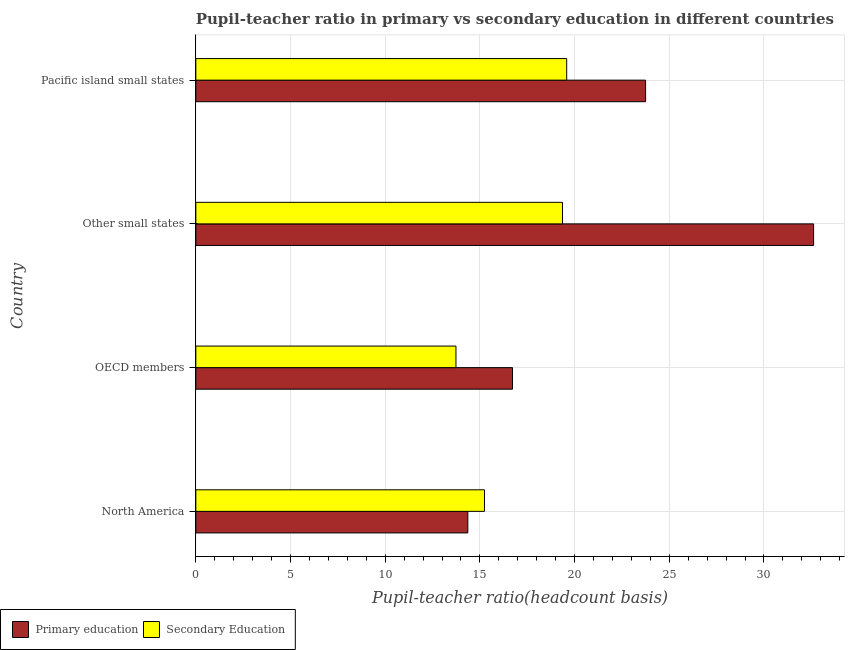How many groups of bars are there?
Make the answer very short. 4. Are the number of bars on each tick of the Y-axis equal?
Provide a short and direct response. Yes. How many bars are there on the 4th tick from the top?
Make the answer very short. 2. How many bars are there on the 2nd tick from the bottom?
Give a very brief answer. 2. What is the pupil-teacher ratio in primary education in OECD members?
Provide a succinct answer. 16.72. Across all countries, what is the maximum pupil teacher ratio on secondary education?
Make the answer very short. 19.58. Across all countries, what is the minimum pupil-teacher ratio in primary education?
Provide a short and direct response. 14.36. In which country was the pupil-teacher ratio in primary education maximum?
Give a very brief answer. Other small states. What is the total pupil teacher ratio on secondary education in the graph?
Offer a very short reply. 67.92. What is the difference between the pupil-teacher ratio in primary education in North America and that in OECD members?
Provide a succinct answer. -2.36. What is the difference between the pupil teacher ratio on secondary education in OECD members and the pupil-teacher ratio in primary education in Other small states?
Provide a short and direct response. -18.89. What is the average pupil teacher ratio on secondary education per country?
Your answer should be compact. 16.98. What is the difference between the pupil teacher ratio on secondary education and pupil-teacher ratio in primary education in OECD members?
Keep it short and to the point. -2.99. In how many countries, is the pupil teacher ratio on secondary education greater than 20 ?
Provide a succinct answer. 0. What is the ratio of the pupil-teacher ratio in primary education in North America to that in Pacific island small states?
Provide a short and direct response. 0.6. Is the pupil-teacher ratio in primary education in North America less than that in Pacific island small states?
Ensure brevity in your answer.  Yes. Is the difference between the pupil teacher ratio on secondary education in North America and Pacific island small states greater than the difference between the pupil-teacher ratio in primary education in North America and Pacific island small states?
Your answer should be compact. Yes. What is the difference between the highest and the second highest pupil teacher ratio on secondary education?
Provide a succinct answer. 0.22. What is the difference between the highest and the lowest pupil-teacher ratio in primary education?
Give a very brief answer. 18.26. What does the 1st bar from the top in Pacific island small states represents?
Make the answer very short. Secondary Education. What does the 2nd bar from the bottom in Pacific island small states represents?
Offer a very short reply. Secondary Education. How many bars are there?
Your answer should be compact. 8. How many countries are there in the graph?
Make the answer very short. 4. What is the difference between two consecutive major ticks on the X-axis?
Your answer should be compact. 5. Are the values on the major ticks of X-axis written in scientific E-notation?
Provide a short and direct response. No. How many legend labels are there?
Offer a terse response. 2. What is the title of the graph?
Your answer should be compact. Pupil-teacher ratio in primary vs secondary education in different countries. Does "Fertility rate" appear as one of the legend labels in the graph?
Give a very brief answer. No. What is the label or title of the X-axis?
Your answer should be compact. Pupil-teacher ratio(headcount basis). What is the label or title of the Y-axis?
Offer a terse response. Country. What is the Pupil-teacher ratio(headcount basis) of Primary education in North America?
Offer a very short reply. 14.36. What is the Pupil-teacher ratio(headcount basis) in Secondary Education in North America?
Provide a short and direct response. 15.24. What is the Pupil-teacher ratio(headcount basis) of Primary education in OECD members?
Give a very brief answer. 16.72. What is the Pupil-teacher ratio(headcount basis) of Secondary Education in OECD members?
Provide a succinct answer. 13.74. What is the Pupil-teacher ratio(headcount basis) of Primary education in Other small states?
Your response must be concise. 32.62. What is the Pupil-teacher ratio(headcount basis) in Secondary Education in Other small states?
Ensure brevity in your answer.  19.36. What is the Pupil-teacher ratio(headcount basis) in Primary education in Pacific island small states?
Keep it short and to the point. 23.75. What is the Pupil-teacher ratio(headcount basis) in Secondary Education in Pacific island small states?
Your answer should be compact. 19.58. Across all countries, what is the maximum Pupil-teacher ratio(headcount basis) in Primary education?
Keep it short and to the point. 32.62. Across all countries, what is the maximum Pupil-teacher ratio(headcount basis) of Secondary Education?
Offer a terse response. 19.58. Across all countries, what is the minimum Pupil-teacher ratio(headcount basis) in Primary education?
Your answer should be very brief. 14.36. Across all countries, what is the minimum Pupil-teacher ratio(headcount basis) in Secondary Education?
Give a very brief answer. 13.74. What is the total Pupil-teacher ratio(headcount basis) of Primary education in the graph?
Make the answer very short. 87.46. What is the total Pupil-teacher ratio(headcount basis) in Secondary Education in the graph?
Give a very brief answer. 67.92. What is the difference between the Pupil-teacher ratio(headcount basis) of Primary education in North America and that in OECD members?
Provide a short and direct response. -2.36. What is the difference between the Pupil-teacher ratio(headcount basis) in Secondary Education in North America and that in OECD members?
Offer a terse response. 1.51. What is the difference between the Pupil-teacher ratio(headcount basis) in Primary education in North America and that in Other small states?
Your answer should be compact. -18.26. What is the difference between the Pupil-teacher ratio(headcount basis) of Secondary Education in North America and that in Other small states?
Provide a succinct answer. -4.12. What is the difference between the Pupil-teacher ratio(headcount basis) in Primary education in North America and that in Pacific island small states?
Your response must be concise. -9.39. What is the difference between the Pupil-teacher ratio(headcount basis) of Secondary Education in North America and that in Pacific island small states?
Your answer should be very brief. -4.34. What is the difference between the Pupil-teacher ratio(headcount basis) in Primary education in OECD members and that in Other small states?
Make the answer very short. -15.9. What is the difference between the Pupil-teacher ratio(headcount basis) in Secondary Education in OECD members and that in Other small states?
Provide a short and direct response. -5.63. What is the difference between the Pupil-teacher ratio(headcount basis) in Primary education in OECD members and that in Pacific island small states?
Your answer should be compact. -7.03. What is the difference between the Pupil-teacher ratio(headcount basis) of Secondary Education in OECD members and that in Pacific island small states?
Your answer should be very brief. -5.85. What is the difference between the Pupil-teacher ratio(headcount basis) in Primary education in Other small states and that in Pacific island small states?
Your response must be concise. 8.87. What is the difference between the Pupil-teacher ratio(headcount basis) of Secondary Education in Other small states and that in Pacific island small states?
Ensure brevity in your answer.  -0.22. What is the difference between the Pupil-teacher ratio(headcount basis) in Primary education in North America and the Pupil-teacher ratio(headcount basis) in Secondary Education in OECD members?
Your answer should be very brief. 0.63. What is the difference between the Pupil-teacher ratio(headcount basis) in Primary education in North America and the Pupil-teacher ratio(headcount basis) in Secondary Education in Other small states?
Your response must be concise. -5. What is the difference between the Pupil-teacher ratio(headcount basis) in Primary education in North America and the Pupil-teacher ratio(headcount basis) in Secondary Education in Pacific island small states?
Provide a succinct answer. -5.22. What is the difference between the Pupil-teacher ratio(headcount basis) of Primary education in OECD members and the Pupil-teacher ratio(headcount basis) of Secondary Education in Other small states?
Make the answer very short. -2.64. What is the difference between the Pupil-teacher ratio(headcount basis) of Primary education in OECD members and the Pupil-teacher ratio(headcount basis) of Secondary Education in Pacific island small states?
Offer a very short reply. -2.86. What is the difference between the Pupil-teacher ratio(headcount basis) in Primary education in Other small states and the Pupil-teacher ratio(headcount basis) in Secondary Education in Pacific island small states?
Provide a short and direct response. 13.04. What is the average Pupil-teacher ratio(headcount basis) of Primary education per country?
Offer a terse response. 21.86. What is the average Pupil-teacher ratio(headcount basis) in Secondary Education per country?
Offer a very short reply. 16.98. What is the difference between the Pupil-teacher ratio(headcount basis) of Primary education and Pupil-teacher ratio(headcount basis) of Secondary Education in North America?
Give a very brief answer. -0.88. What is the difference between the Pupil-teacher ratio(headcount basis) in Primary education and Pupil-teacher ratio(headcount basis) in Secondary Education in OECD members?
Your answer should be very brief. 2.99. What is the difference between the Pupil-teacher ratio(headcount basis) in Primary education and Pupil-teacher ratio(headcount basis) in Secondary Education in Other small states?
Your response must be concise. 13.26. What is the difference between the Pupil-teacher ratio(headcount basis) of Primary education and Pupil-teacher ratio(headcount basis) of Secondary Education in Pacific island small states?
Offer a terse response. 4.17. What is the ratio of the Pupil-teacher ratio(headcount basis) in Primary education in North America to that in OECD members?
Your answer should be very brief. 0.86. What is the ratio of the Pupil-teacher ratio(headcount basis) of Secondary Education in North America to that in OECD members?
Offer a very short reply. 1.11. What is the ratio of the Pupil-teacher ratio(headcount basis) of Primary education in North America to that in Other small states?
Your response must be concise. 0.44. What is the ratio of the Pupil-teacher ratio(headcount basis) in Secondary Education in North America to that in Other small states?
Offer a terse response. 0.79. What is the ratio of the Pupil-teacher ratio(headcount basis) of Primary education in North America to that in Pacific island small states?
Keep it short and to the point. 0.6. What is the ratio of the Pupil-teacher ratio(headcount basis) of Secondary Education in North America to that in Pacific island small states?
Ensure brevity in your answer.  0.78. What is the ratio of the Pupil-teacher ratio(headcount basis) of Primary education in OECD members to that in Other small states?
Your answer should be very brief. 0.51. What is the ratio of the Pupil-teacher ratio(headcount basis) of Secondary Education in OECD members to that in Other small states?
Your answer should be very brief. 0.71. What is the ratio of the Pupil-teacher ratio(headcount basis) in Primary education in OECD members to that in Pacific island small states?
Give a very brief answer. 0.7. What is the ratio of the Pupil-teacher ratio(headcount basis) of Secondary Education in OECD members to that in Pacific island small states?
Offer a terse response. 0.7. What is the ratio of the Pupil-teacher ratio(headcount basis) in Primary education in Other small states to that in Pacific island small states?
Provide a succinct answer. 1.37. What is the ratio of the Pupil-teacher ratio(headcount basis) in Secondary Education in Other small states to that in Pacific island small states?
Your response must be concise. 0.99. What is the difference between the highest and the second highest Pupil-teacher ratio(headcount basis) of Primary education?
Offer a terse response. 8.87. What is the difference between the highest and the second highest Pupil-teacher ratio(headcount basis) in Secondary Education?
Provide a succinct answer. 0.22. What is the difference between the highest and the lowest Pupil-teacher ratio(headcount basis) in Primary education?
Your response must be concise. 18.26. What is the difference between the highest and the lowest Pupil-teacher ratio(headcount basis) of Secondary Education?
Keep it short and to the point. 5.85. 